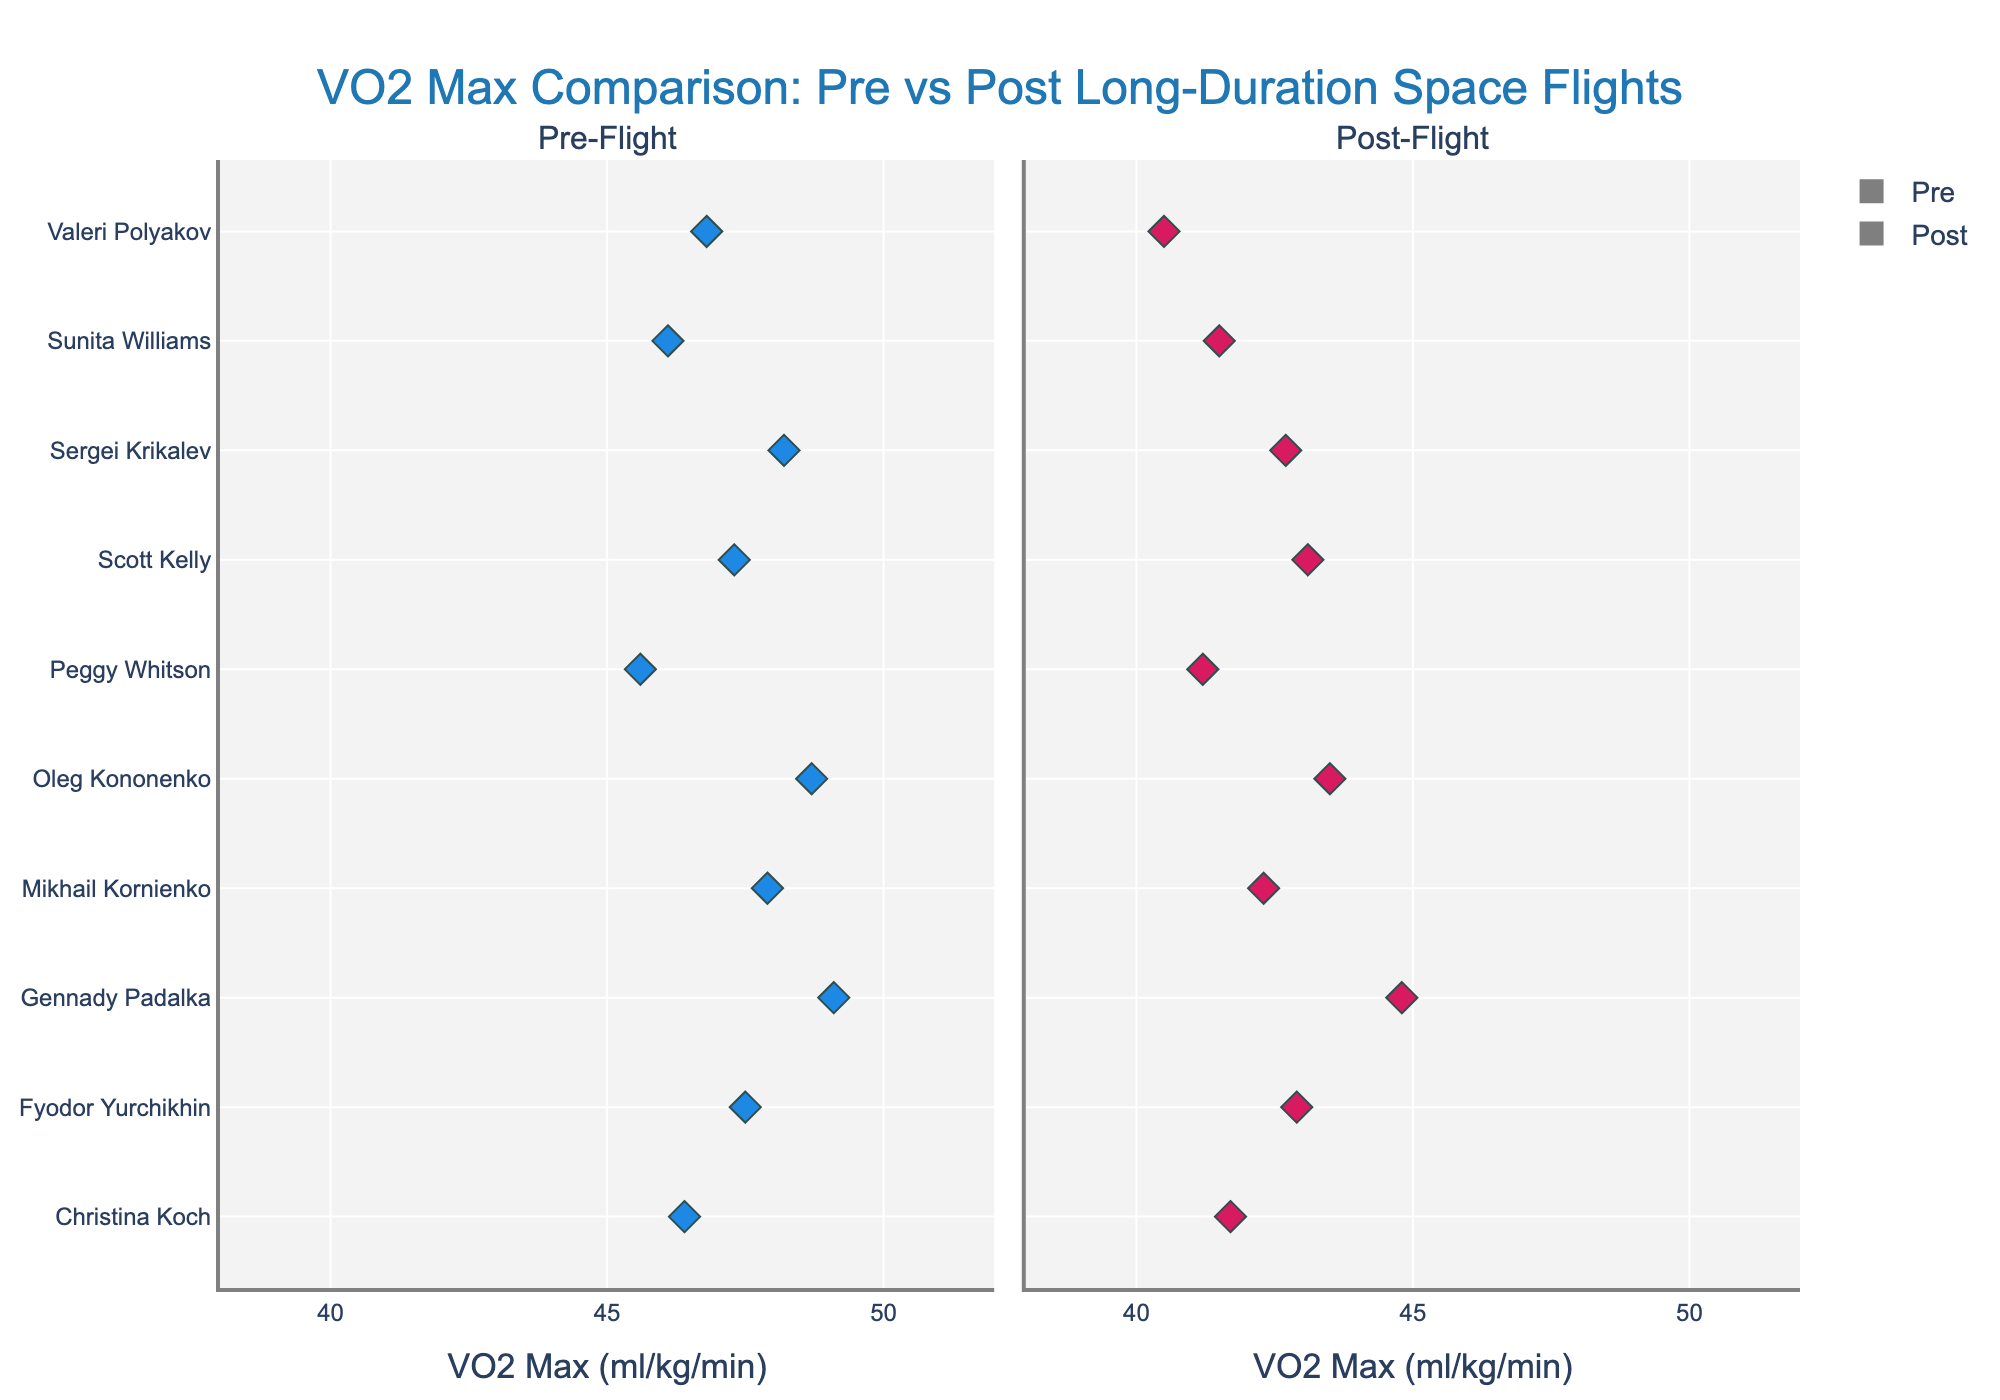What is the title of the figure? The title is prominently displayed at the top of the figure, providing a summary of what the plot represents.
Answer: VO2 Max Comparison: Pre vs Post Long-Duration Space Flights How many individuals are represented in the plot? Count the number of distinct names on the y-axis.
Answer: 10 What's the variable displayed on the x-axis? The x-axis title is clearly labeled.
Answer: VO2 Max (ml/kg/min) Which individual has the highest pre-flight VO2 Max value? Look at the Pre-Flight box plot and identify the name of the individual with the highest value.
Answer: Gennady Padalka How does Sergei Krikalev's post-flight VO2 Max compare to his pre-flight value? Find the data points for Sergei Krikalev in both the Pre-Flight and Post-Flight plots and compare the values.
Answer: Decreased What is the range of VO2 Max values depicted in the plot? Identify the minimum and maximum values on the x-axis.
Answer: 38 to 52 What's the average post-flight VO2 Max value for all individuals? Sum all post-flight VO2 Max values and divide by the number of individuals. Average of (42.7 + 40.5 + 41.2 + 43.1 + 44.8 + 42.9 + 41.7 + 43.5 + 42.3 + 41.5) = 424.2 / 10.
Answer: 42.4 Which individual shows the largest decline in VO2 Max after the flight? Calculate the difference between pre-flight and post-flight VO2 Max values for each individual and find the largest decline.
Answer: Valeri Polyakov (46.8 - 40.5 = 6.3) What is the median post-flight VO2 Max value? Arrange the post-flight values in ascending order and find the middle value. Post-flight values in order: 40.5, 41.2, 41.5, 41.7, 42.3, 42.7, 42.9, 43.1, 43.5, 44.8 — Median is the average of the 5th and 6th values (42.3 + 42.7) / 2.
Answer: 42.5 What is the color used for the markers in the post-flight plot? Identify the color of the marker points in the Post-Flight plot.
Answer: Red 